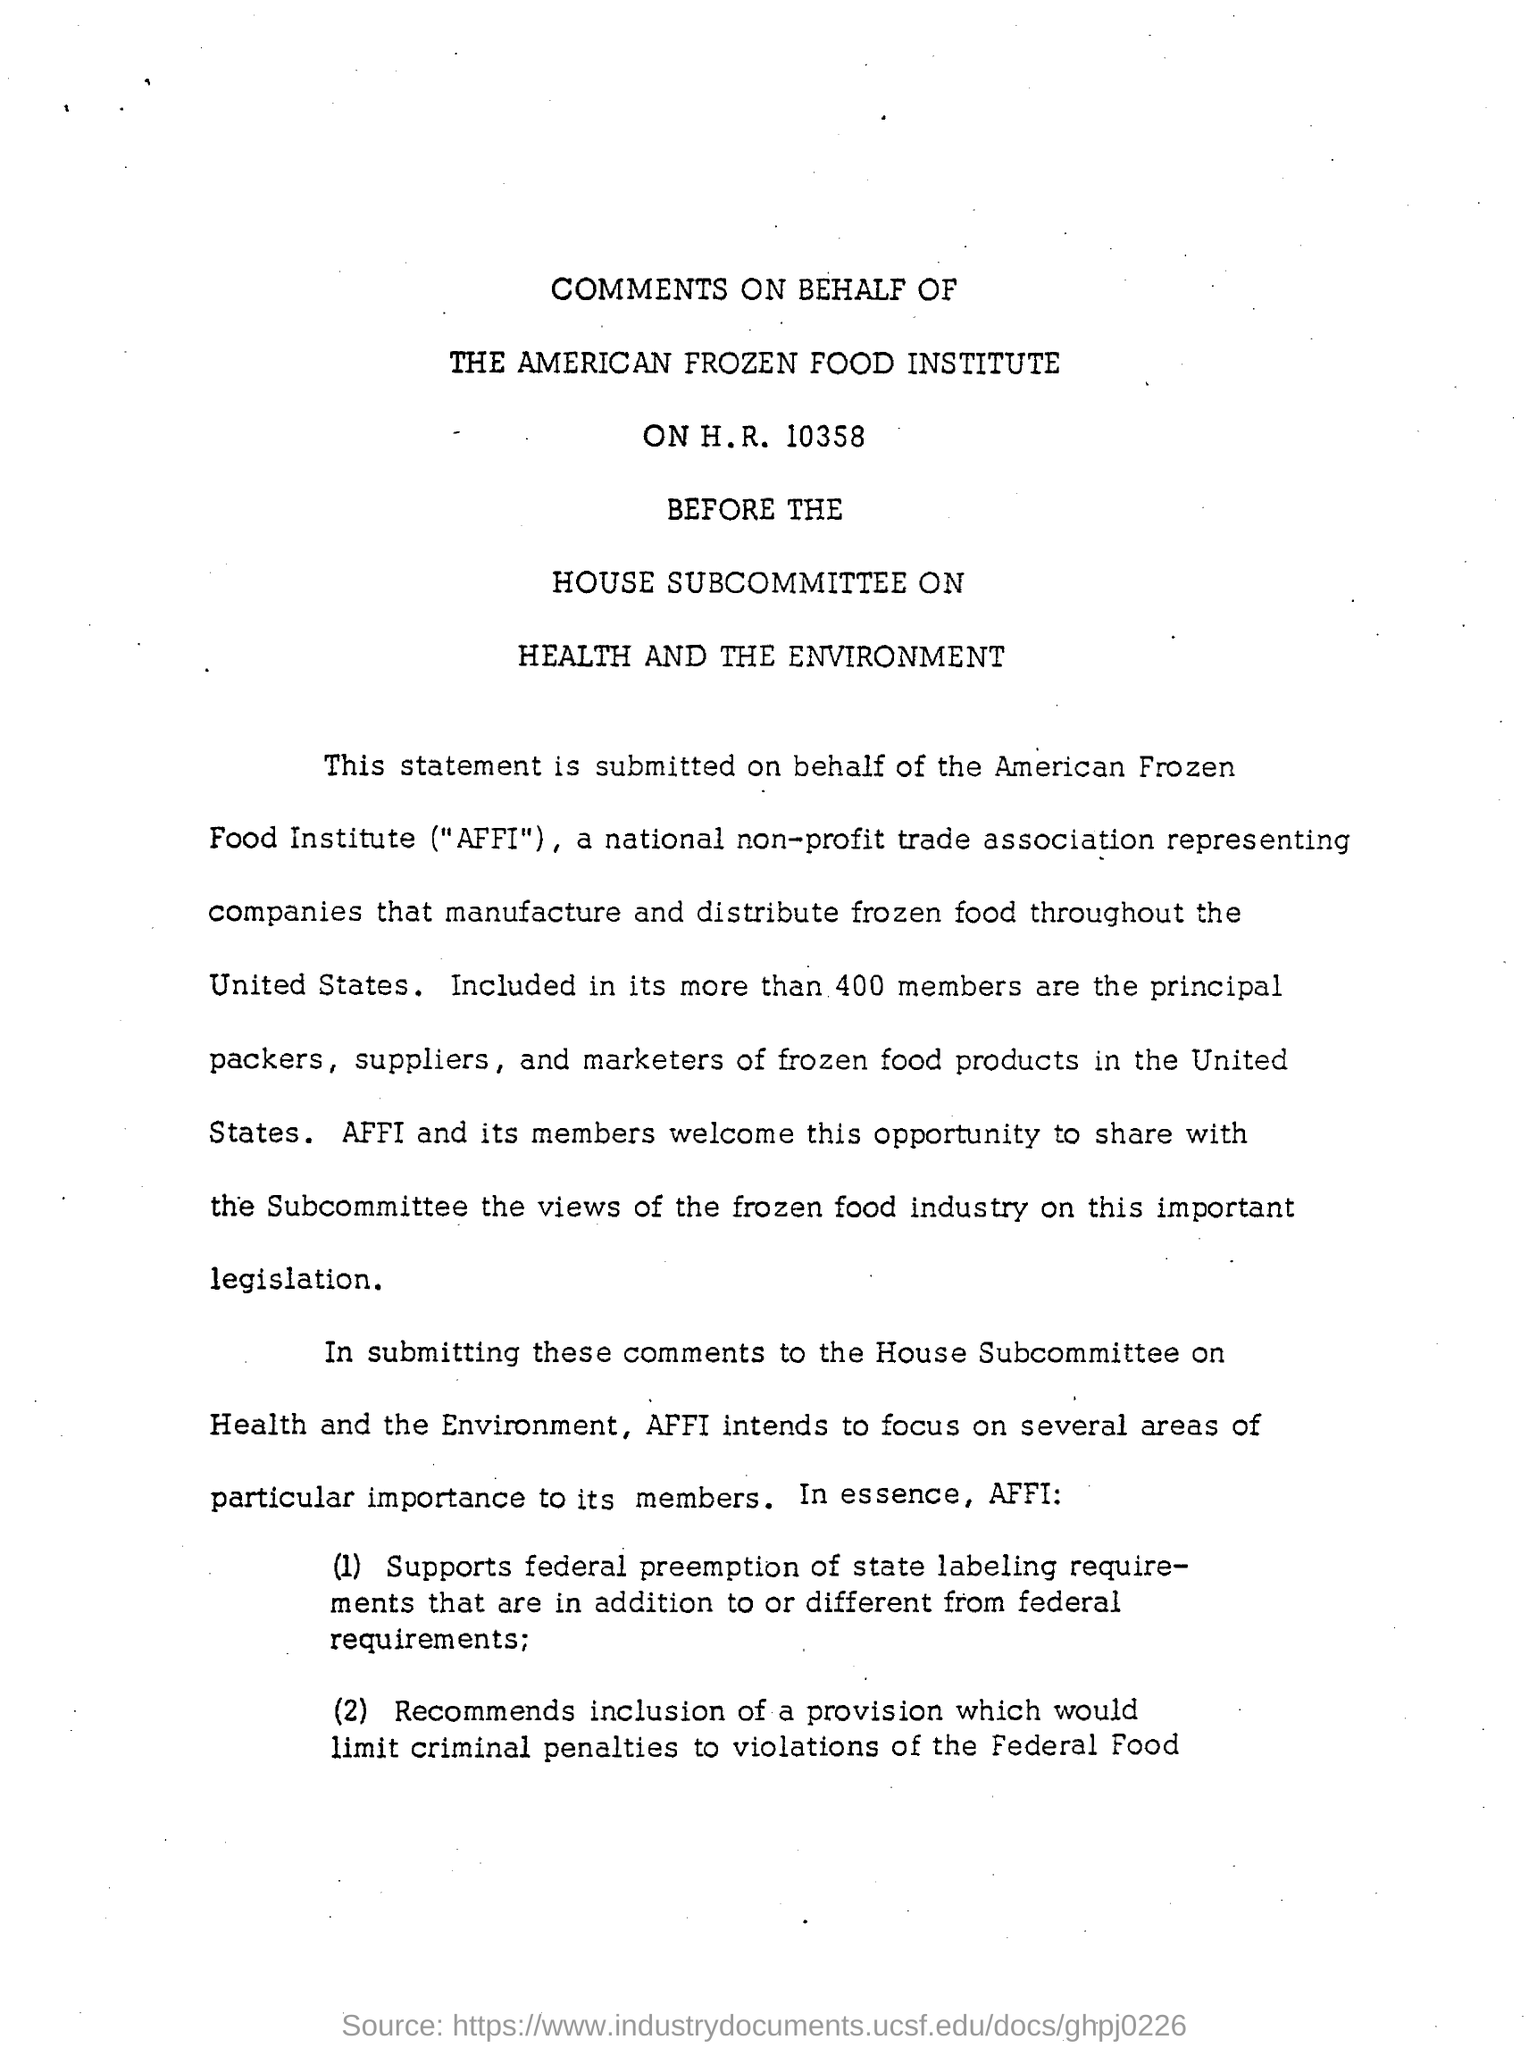What is the name of the food institute?
Offer a terse response. American Frozen food Institute. How many members are included in the frozen food institute?
Offer a terse response. More than 400 members. AFFI stands for ?
Your response must be concise. American Frozen Food Institute. This statement or comments is submitted on behalf of?
Ensure brevity in your answer.  The American Frozen food institute ("AFFI"). 